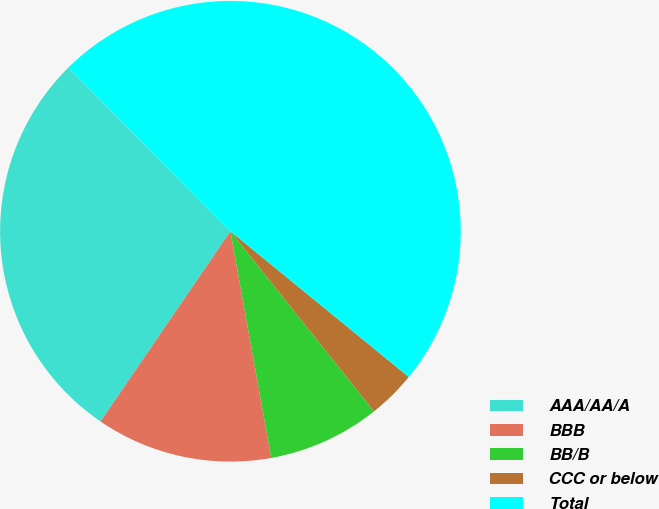Convert chart. <chart><loc_0><loc_0><loc_500><loc_500><pie_chart><fcel>AAA/AA/A<fcel>BBB<fcel>BB/B<fcel>CCC or below<fcel>Total<nl><fcel>28.03%<fcel>12.37%<fcel>7.88%<fcel>3.38%<fcel>48.33%<nl></chart> 